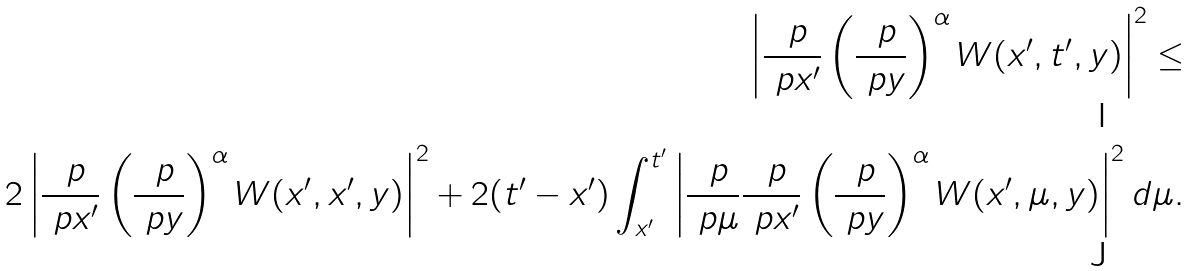<formula> <loc_0><loc_0><loc_500><loc_500>\left | \frac { \ p } { \ p x ^ { \prime } } \left ( \frac { \ p } { \ p y } \right ) ^ { \alpha } W ( x ^ { \prime } , t ^ { \prime } , y ) \right | ^ { 2 } \leq \\ 2 \left | \frac { \ p } { \ p x ^ { \prime } } \left ( \frac { \ p } { \ p y } \right ) ^ { \alpha } W ( x ^ { \prime } , x ^ { \prime } , y ) \right | ^ { 2 } + 2 ( t ^ { \prime } - x ^ { \prime } ) \int _ { x ^ { \prime } } ^ { t ^ { \prime } } \left | \frac { \ p } { \ p \mu } \frac { \ p } { \ p x ^ { \prime } } \left ( \frac { \ p } { \ p y } \right ) ^ { \alpha } W ( x ^ { \prime } , \mu , y ) \right | ^ { 2 } d \mu .</formula> 